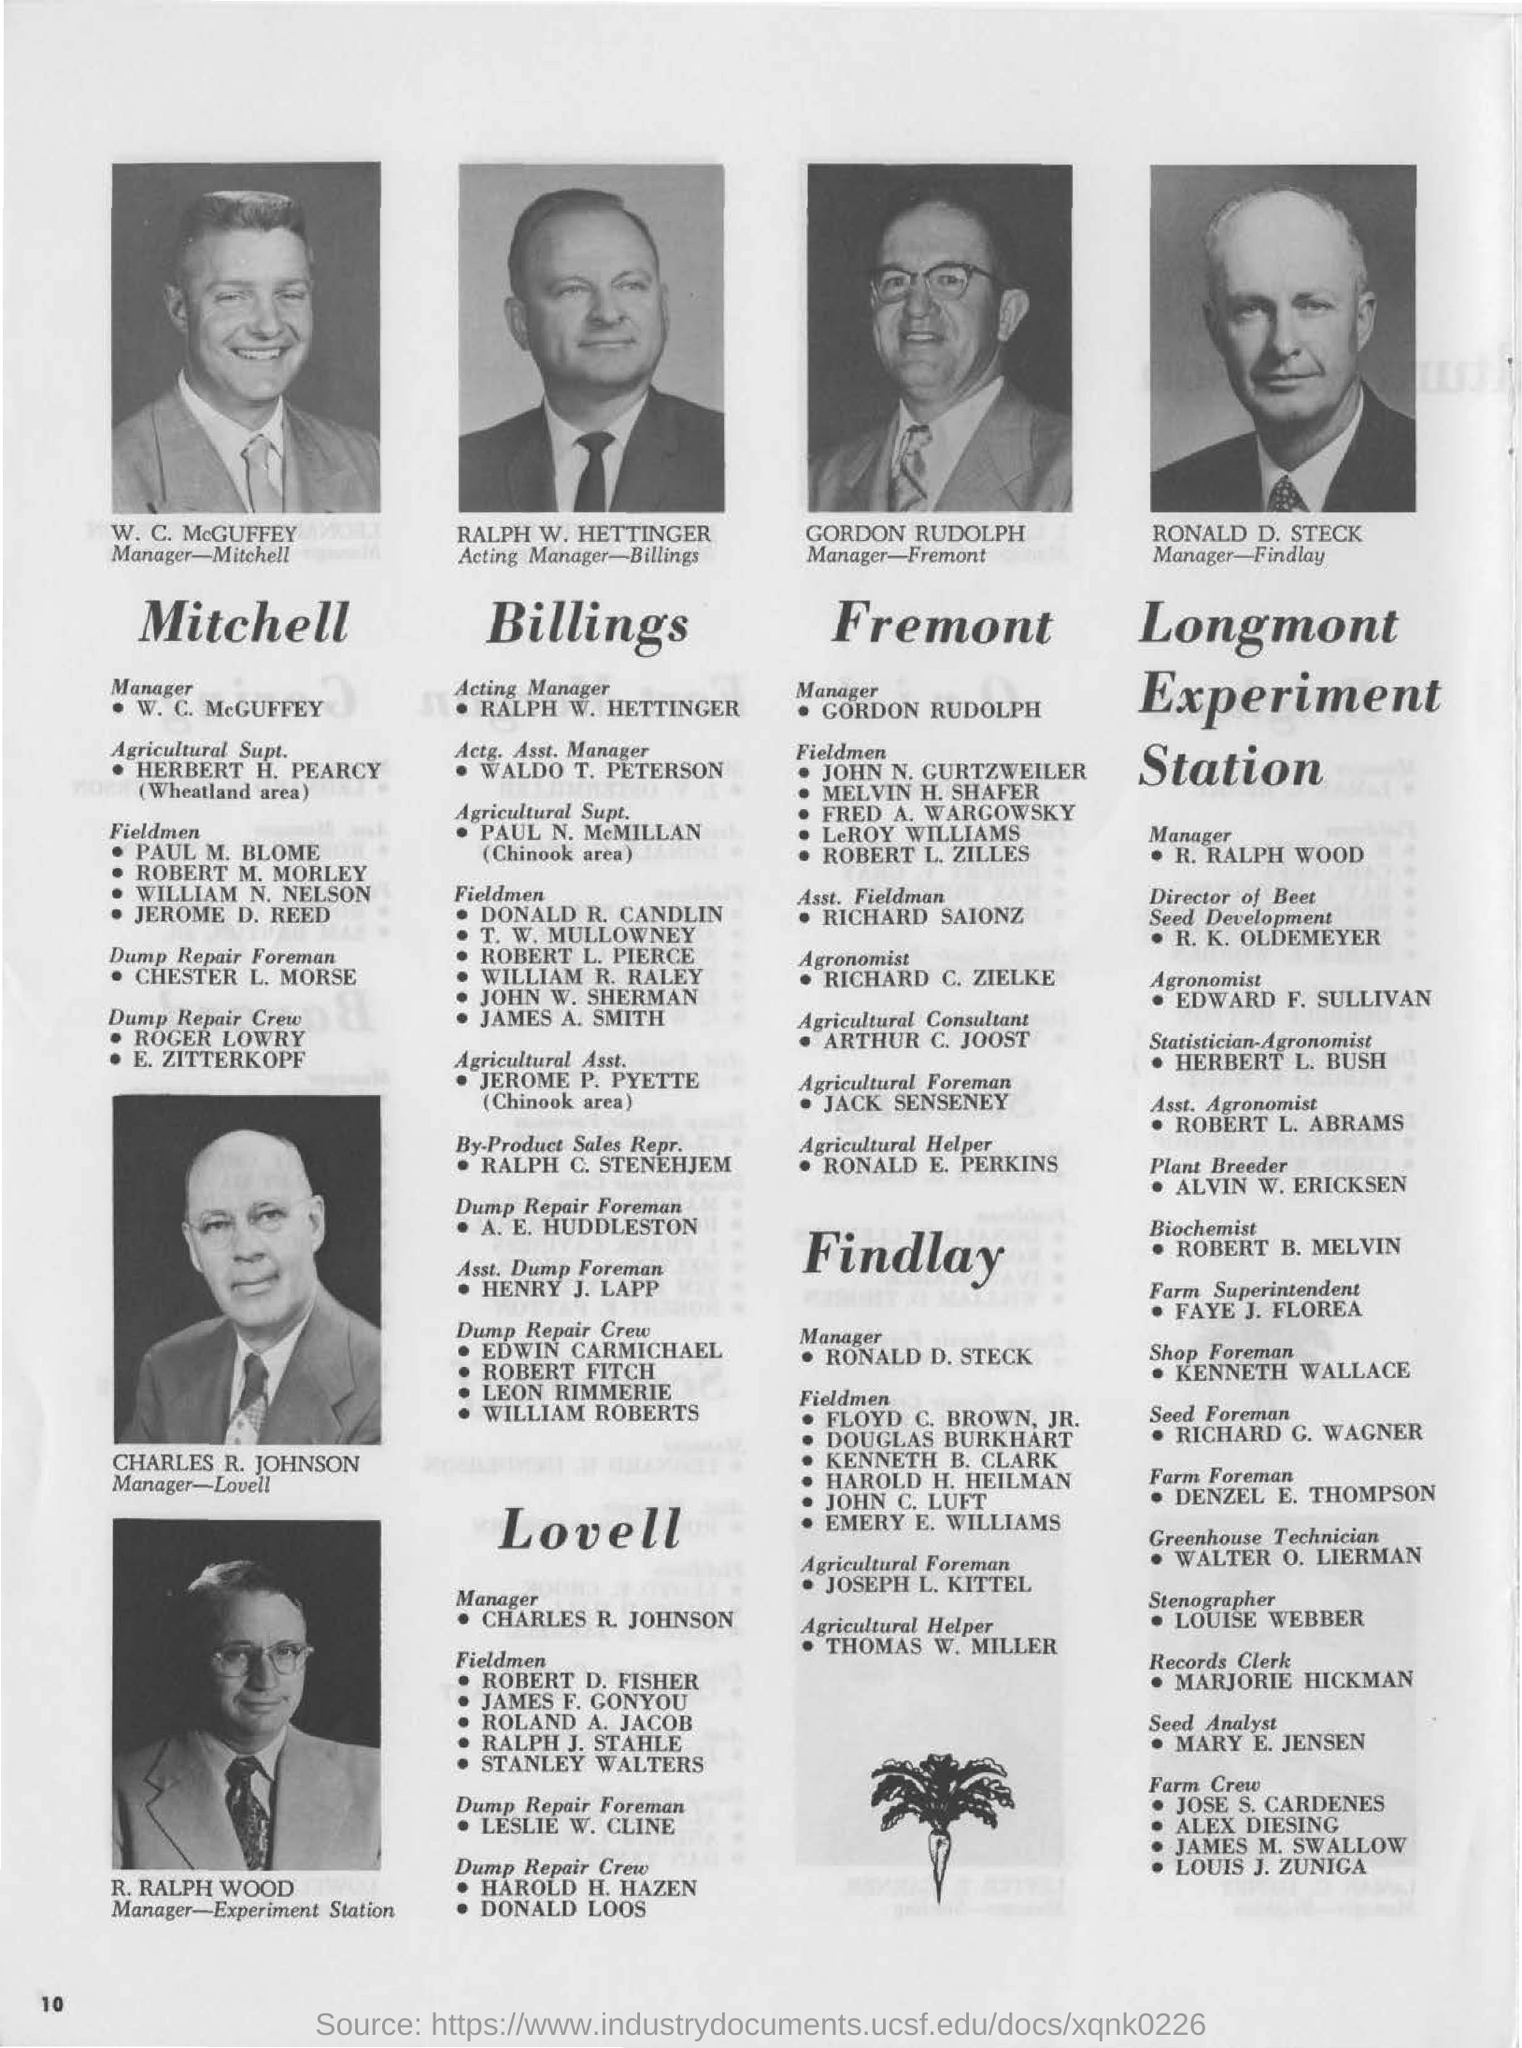Who is the manger-mitchell?
Make the answer very short. W. C. McGUFFEY. Who is the acting manager-billings?
Give a very brief answer. Ralph w. hettinger. Who is the agricultural foreman at "findlay"?
Provide a short and direct response. Joseph l. kittel. 